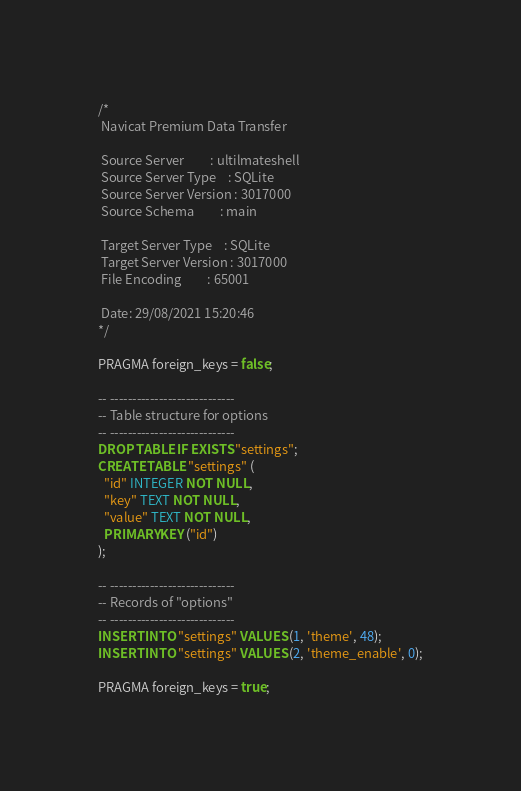Convert code to text. <code><loc_0><loc_0><loc_500><loc_500><_SQL_>/*
 Navicat Premium Data Transfer

 Source Server         : ultilmateshell
 Source Server Type    : SQLite
 Source Server Version : 3017000
 Source Schema         : main

 Target Server Type    : SQLite
 Target Server Version : 3017000
 File Encoding         : 65001

 Date: 29/08/2021 15:20:46
*/

PRAGMA foreign_keys = false;

-- ----------------------------
-- Table structure for options
-- ----------------------------
DROP TABLE IF EXISTS "settings";
CREATE TABLE "settings" (
  "id" INTEGER NOT NULL,
  "key" TEXT NOT NULL,
  "value" TEXT NOT NULL,
  PRIMARY KEY ("id")
);

-- ----------------------------
-- Records of "options"
-- ----------------------------
INSERT INTO "settings" VALUES (1, 'theme', 48);
INSERT INTO "settings" VALUES (2, 'theme_enable', 0);

PRAGMA foreign_keys = true;
</code> 